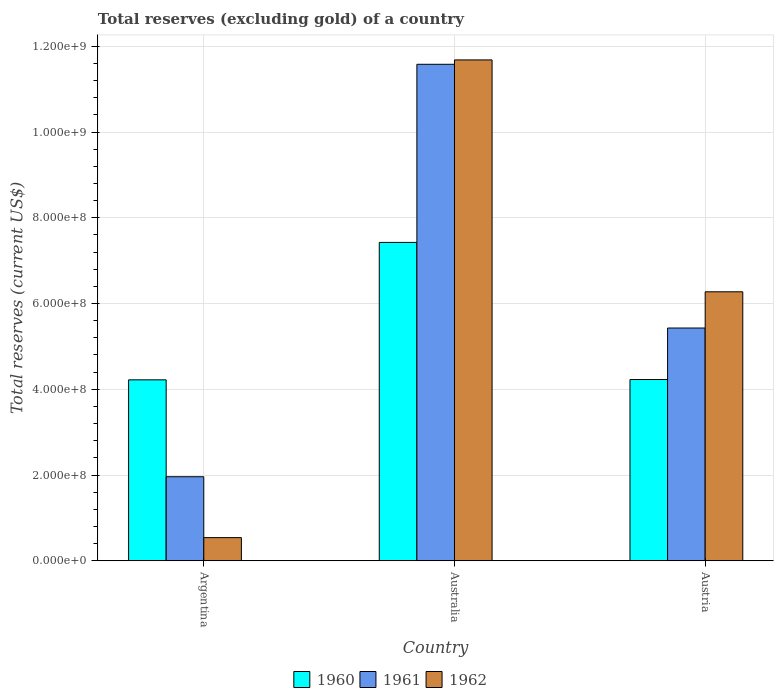How many groups of bars are there?
Give a very brief answer. 3. Are the number of bars on each tick of the X-axis equal?
Keep it short and to the point. Yes. How many bars are there on the 1st tick from the left?
Provide a succinct answer. 3. What is the total reserves (excluding gold) in 1961 in Austria?
Make the answer very short. 5.43e+08. Across all countries, what is the maximum total reserves (excluding gold) in 1960?
Ensure brevity in your answer.  7.43e+08. Across all countries, what is the minimum total reserves (excluding gold) in 1962?
Your answer should be compact. 5.40e+07. In which country was the total reserves (excluding gold) in 1961 maximum?
Your response must be concise. Australia. What is the total total reserves (excluding gold) in 1960 in the graph?
Provide a succinct answer. 1.59e+09. What is the difference between the total reserves (excluding gold) in 1962 in Australia and that in Austria?
Offer a terse response. 5.41e+08. What is the difference between the total reserves (excluding gold) in 1962 in Austria and the total reserves (excluding gold) in 1960 in Australia?
Offer a very short reply. -1.15e+08. What is the average total reserves (excluding gold) in 1962 per country?
Ensure brevity in your answer.  6.17e+08. What is the difference between the total reserves (excluding gold) of/in 1960 and total reserves (excluding gold) of/in 1961 in Argentina?
Offer a terse response. 2.26e+08. In how many countries, is the total reserves (excluding gold) in 1961 greater than 920000000 US$?
Your answer should be compact. 1. What is the ratio of the total reserves (excluding gold) in 1961 in Australia to that in Austria?
Your response must be concise. 2.13. What is the difference between the highest and the second highest total reserves (excluding gold) in 1962?
Your response must be concise. -5.73e+08. What is the difference between the highest and the lowest total reserves (excluding gold) in 1960?
Your answer should be compact. 3.21e+08. In how many countries, is the total reserves (excluding gold) in 1960 greater than the average total reserves (excluding gold) in 1960 taken over all countries?
Offer a very short reply. 1. Is the sum of the total reserves (excluding gold) in 1962 in Argentina and Australia greater than the maximum total reserves (excluding gold) in 1961 across all countries?
Give a very brief answer. Yes. How many bars are there?
Your response must be concise. 9. Are all the bars in the graph horizontal?
Offer a terse response. No. How many countries are there in the graph?
Your response must be concise. 3. What is the difference between two consecutive major ticks on the Y-axis?
Offer a terse response. 2.00e+08. Are the values on the major ticks of Y-axis written in scientific E-notation?
Ensure brevity in your answer.  Yes. How are the legend labels stacked?
Offer a terse response. Horizontal. What is the title of the graph?
Your answer should be very brief. Total reserves (excluding gold) of a country. What is the label or title of the X-axis?
Provide a short and direct response. Country. What is the label or title of the Y-axis?
Your answer should be very brief. Total reserves (current US$). What is the Total reserves (current US$) in 1960 in Argentina?
Make the answer very short. 4.22e+08. What is the Total reserves (current US$) in 1961 in Argentina?
Your response must be concise. 1.96e+08. What is the Total reserves (current US$) of 1962 in Argentina?
Offer a terse response. 5.40e+07. What is the Total reserves (current US$) in 1960 in Australia?
Your answer should be compact. 7.43e+08. What is the Total reserves (current US$) of 1961 in Australia?
Give a very brief answer. 1.16e+09. What is the Total reserves (current US$) of 1962 in Australia?
Provide a succinct answer. 1.17e+09. What is the Total reserves (current US$) of 1960 in Austria?
Provide a short and direct response. 4.23e+08. What is the Total reserves (current US$) in 1961 in Austria?
Make the answer very short. 5.43e+08. What is the Total reserves (current US$) of 1962 in Austria?
Make the answer very short. 6.27e+08. Across all countries, what is the maximum Total reserves (current US$) in 1960?
Make the answer very short. 7.43e+08. Across all countries, what is the maximum Total reserves (current US$) in 1961?
Offer a terse response. 1.16e+09. Across all countries, what is the maximum Total reserves (current US$) in 1962?
Offer a terse response. 1.17e+09. Across all countries, what is the minimum Total reserves (current US$) of 1960?
Your answer should be very brief. 4.22e+08. Across all countries, what is the minimum Total reserves (current US$) of 1961?
Keep it short and to the point. 1.96e+08. Across all countries, what is the minimum Total reserves (current US$) in 1962?
Provide a succinct answer. 5.40e+07. What is the total Total reserves (current US$) in 1960 in the graph?
Your answer should be very brief. 1.59e+09. What is the total Total reserves (current US$) in 1961 in the graph?
Provide a short and direct response. 1.90e+09. What is the total Total reserves (current US$) of 1962 in the graph?
Offer a terse response. 1.85e+09. What is the difference between the Total reserves (current US$) in 1960 in Argentina and that in Australia?
Provide a short and direct response. -3.21e+08. What is the difference between the Total reserves (current US$) in 1961 in Argentina and that in Australia?
Ensure brevity in your answer.  -9.62e+08. What is the difference between the Total reserves (current US$) in 1962 in Argentina and that in Australia?
Provide a succinct answer. -1.11e+09. What is the difference between the Total reserves (current US$) of 1960 in Argentina and that in Austria?
Keep it short and to the point. -7.60e+05. What is the difference between the Total reserves (current US$) of 1961 in Argentina and that in Austria?
Make the answer very short. -3.47e+08. What is the difference between the Total reserves (current US$) in 1962 in Argentina and that in Austria?
Your response must be concise. -5.73e+08. What is the difference between the Total reserves (current US$) in 1960 in Australia and that in Austria?
Make the answer very short. 3.20e+08. What is the difference between the Total reserves (current US$) of 1961 in Australia and that in Austria?
Your answer should be very brief. 6.15e+08. What is the difference between the Total reserves (current US$) of 1962 in Australia and that in Austria?
Your response must be concise. 5.41e+08. What is the difference between the Total reserves (current US$) of 1960 in Argentina and the Total reserves (current US$) of 1961 in Australia?
Make the answer very short. -7.36e+08. What is the difference between the Total reserves (current US$) of 1960 in Argentina and the Total reserves (current US$) of 1962 in Australia?
Provide a short and direct response. -7.46e+08. What is the difference between the Total reserves (current US$) in 1961 in Argentina and the Total reserves (current US$) in 1962 in Australia?
Ensure brevity in your answer.  -9.72e+08. What is the difference between the Total reserves (current US$) of 1960 in Argentina and the Total reserves (current US$) of 1961 in Austria?
Your answer should be compact. -1.21e+08. What is the difference between the Total reserves (current US$) in 1960 in Argentina and the Total reserves (current US$) in 1962 in Austria?
Give a very brief answer. -2.05e+08. What is the difference between the Total reserves (current US$) in 1961 in Argentina and the Total reserves (current US$) in 1962 in Austria?
Make the answer very short. -4.31e+08. What is the difference between the Total reserves (current US$) of 1960 in Australia and the Total reserves (current US$) of 1961 in Austria?
Make the answer very short. 2.00e+08. What is the difference between the Total reserves (current US$) of 1960 in Australia and the Total reserves (current US$) of 1962 in Austria?
Ensure brevity in your answer.  1.15e+08. What is the difference between the Total reserves (current US$) in 1961 in Australia and the Total reserves (current US$) in 1962 in Austria?
Offer a very short reply. 5.31e+08. What is the average Total reserves (current US$) in 1960 per country?
Keep it short and to the point. 5.29e+08. What is the average Total reserves (current US$) of 1961 per country?
Offer a terse response. 6.32e+08. What is the average Total reserves (current US$) of 1962 per country?
Make the answer very short. 6.17e+08. What is the difference between the Total reserves (current US$) in 1960 and Total reserves (current US$) in 1961 in Argentina?
Your response must be concise. 2.26e+08. What is the difference between the Total reserves (current US$) of 1960 and Total reserves (current US$) of 1962 in Argentina?
Keep it short and to the point. 3.68e+08. What is the difference between the Total reserves (current US$) of 1961 and Total reserves (current US$) of 1962 in Argentina?
Ensure brevity in your answer.  1.42e+08. What is the difference between the Total reserves (current US$) of 1960 and Total reserves (current US$) of 1961 in Australia?
Keep it short and to the point. -4.15e+08. What is the difference between the Total reserves (current US$) in 1960 and Total reserves (current US$) in 1962 in Australia?
Provide a short and direct response. -4.26e+08. What is the difference between the Total reserves (current US$) of 1961 and Total reserves (current US$) of 1962 in Australia?
Keep it short and to the point. -1.02e+07. What is the difference between the Total reserves (current US$) of 1960 and Total reserves (current US$) of 1961 in Austria?
Offer a terse response. -1.20e+08. What is the difference between the Total reserves (current US$) in 1960 and Total reserves (current US$) in 1962 in Austria?
Make the answer very short. -2.05e+08. What is the difference between the Total reserves (current US$) in 1961 and Total reserves (current US$) in 1962 in Austria?
Ensure brevity in your answer.  -8.45e+07. What is the ratio of the Total reserves (current US$) of 1960 in Argentina to that in Australia?
Your answer should be compact. 0.57. What is the ratio of the Total reserves (current US$) of 1961 in Argentina to that in Australia?
Your answer should be compact. 0.17. What is the ratio of the Total reserves (current US$) in 1962 in Argentina to that in Australia?
Your response must be concise. 0.05. What is the ratio of the Total reserves (current US$) in 1960 in Argentina to that in Austria?
Your answer should be very brief. 1. What is the ratio of the Total reserves (current US$) in 1961 in Argentina to that in Austria?
Your answer should be compact. 0.36. What is the ratio of the Total reserves (current US$) in 1962 in Argentina to that in Austria?
Ensure brevity in your answer.  0.09. What is the ratio of the Total reserves (current US$) in 1960 in Australia to that in Austria?
Make the answer very short. 1.76. What is the ratio of the Total reserves (current US$) of 1961 in Australia to that in Austria?
Provide a succinct answer. 2.13. What is the ratio of the Total reserves (current US$) of 1962 in Australia to that in Austria?
Provide a short and direct response. 1.86. What is the difference between the highest and the second highest Total reserves (current US$) in 1960?
Provide a short and direct response. 3.20e+08. What is the difference between the highest and the second highest Total reserves (current US$) in 1961?
Ensure brevity in your answer.  6.15e+08. What is the difference between the highest and the second highest Total reserves (current US$) of 1962?
Offer a terse response. 5.41e+08. What is the difference between the highest and the lowest Total reserves (current US$) in 1960?
Offer a very short reply. 3.21e+08. What is the difference between the highest and the lowest Total reserves (current US$) in 1961?
Your answer should be compact. 9.62e+08. What is the difference between the highest and the lowest Total reserves (current US$) of 1962?
Give a very brief answer. 1.11e+09. 